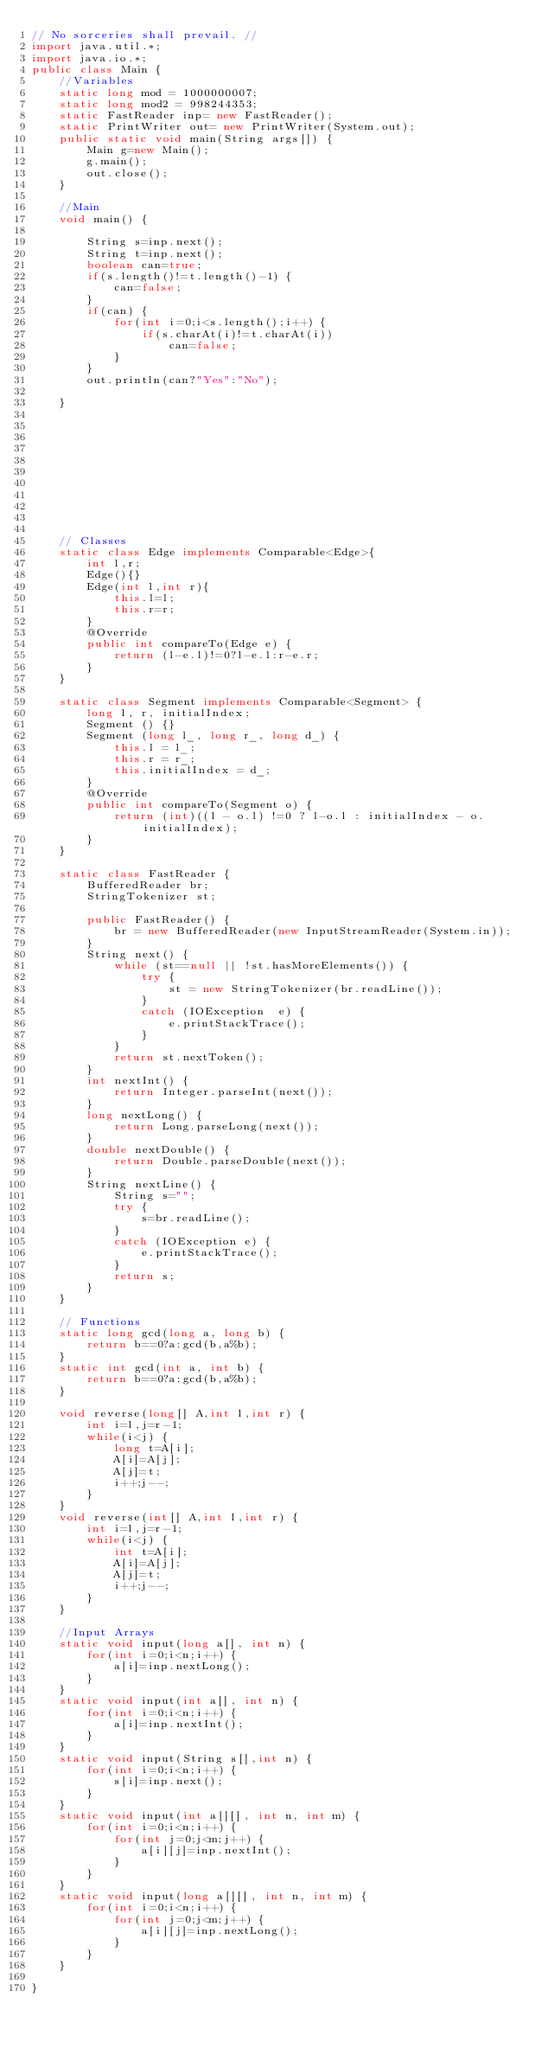Convert code to text. <code><loc_0><loc_0><loc_500><loc_500><_Java_>// No sorceries shall prevail. //           
import java.util.*;
import java.io.*;
public class Main {
	//Variables
	static long mod = 1000000007;
	static long mod2 = 998244353;
	static FastReader inp= new FastReader();
	static PrintWriter out= new PrintWriter(System.out);
	public static void main(String args[]) {		    	
	   	Main g=new Main();
	   	g.main();
	   	out.close();
	}
	
	//Main
	void main() {
		
		String s=inp.next();
		String t=inp.next();
		boolean can=true;
		if(s.length()!=t.length()-1) {
			can=false;
		}
		if(can) {
			for(int i=0;i<s.length();i++) {
				if(s.charAt(i)!=t.charAt(i))
					can=false;
			}
		}
		out.println(can?"Yes":"No");
		
	}
	
	
	
	
	
	
	
	
	
	
	
	// Classes
	static class Edge implements Comparable<Edge>{
		int l,r;
		Edge(){}
		Edge(int l,int r){
			this.l=l;
			this.r=r;
		}
		@Override
		public int compareTo(Edge e) {
			return (l-e.l)!=0?l-e.l:r-e.r;
		}
	}
	
    static class Segment implements Comparable<Segment> {
		long l, r, initialIndex;
		Segment () {}
		Segment (long l_, long r_, long d_) {
		    this.l = l_;
		    this.r = r_;
		    this.initialIndex = d_;
		}
		@Override
		public int compareTo(Segment o) {
		    return (int)((l - o.l) !=0 ? l-o.l : initialIndex - o.initialIndex);
		}
    }
    
    static class FastReader { 
        BufferedReader br; 
        StringTokenizer st; 
  
        public FastReader() { 
            br = new BufferedReader(new InputStreamReader(System.in)); 
        } 
        String next() { 
            while (st==null || !st.hasMoreElements()) { 
                try { 
                    st = new StringTokenizer(br.readLine()); 
                } 
                catch (IOException  e) { 
                    e.printStackTrace(); 
                } 
            } 
            return st.nextToken(); 
        } 
        int nextInt() { 
            return Integer.parseInt(next()); 
        } 
        long nextLong() { 
            return Long.parseLong(next()); 
        } 
        double nextDouble() { 
            return Double.parseDouble(next()); 
        } 
        String nextLine() { 
            String s=""; 
            try { 
                s=br.readLine(); 
            } 
            catch (IOException e) { 
                e.printStackTrace(); 
            } 
            return s; 
        } 
    } 
    
    // Functions
	static long gcd(long a, long b) { 
		return b==0?a:gcd(b,a%b);
	}
	static int gcd(int a, int b) { 
		return b==0?a:gcd(b,a%b);
	}
	
	void reverse(long[] A,int l,int r) {
        int i=l,j=r-1;
        while(i<j) {
            long t=A[i];
            A[i]=A[j];
            A[j]=t;
            i++;j--;
        }
    }
    void reverse(int[] A,int l,int r) {
        int i=l,j=r-1;
        while(i<j) {
            int t=A[i];
            A[i]=A[j];
            A[j]=t;
            i++;j--;
        }
    }
    
    //Input Arrays
    static void input(long a[], int n) {
		for(int i=0;i<n;i++) {
			a[i]=inp.nextLong();
		}
	}
	static void input(int a[], int n) {
		for(int i=0;i<n;i++) {
			a[i]=inp.nextInt();
		}
	}	
	static void input(String s[],int n) {
		for(int i=0;i<n;i++) {
			s[i]=inp.next();
		}
	}
	static void input(int a[][], int n, int m) {
		for(int i=0;i<n;i++) {
			for(int j=0;j<m;j++) {
				a[i][j]=inp.nextInt();
			}
		}
	}
	static void input(long a[][], int n, int m) {
		for(int i=0;i<n;i++) {
			for(int j=0;j<m;j++) {
				a[i][j]=inp.nextLong();
			}
		}
	}
		
}
</code> 